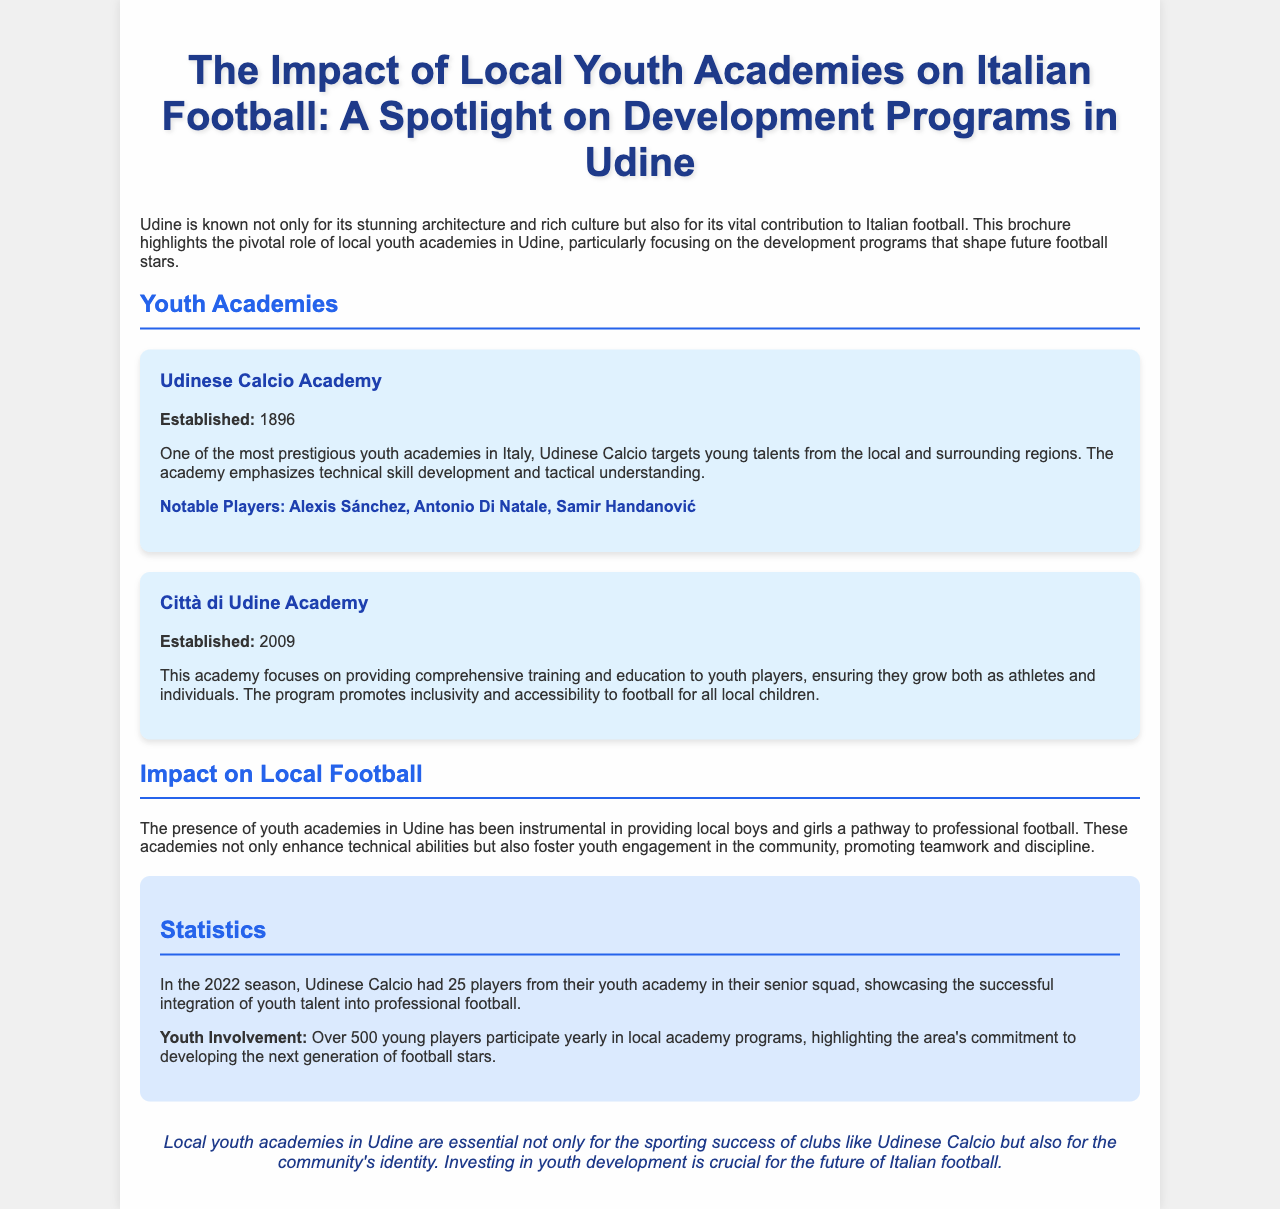What is the title of the brochure? The title provides the main focus of the document, emphasizing youth academies and their impact on local football in Udine.
Answer: The Impact of Local Youth Academies on Italian Football: A Spotlight on Development Programs in Udine When was the Udinese Calcio Academy established? The establishment date of the Udinese Calcio Academy is specifically mentioned in the document.
Answer: 1896 What notable player is associated with the Udinese Calcio Academy? The document lists notable players from this academy, highlighting its successful contributions to professional football.
Answer: Alexis Sánchez How many players from the Udinese Calcio Academy were in the senior squad during the 2022 season? This statistic indicates the integration of academy players into professional football.
Answer: 25 What is the primary focus of the Città di Udine Academy? The focus of this academy is described, showcasing its goals for youth development.
Answer: Comprehensive training and education How many young players participate yearly in local academy programs? This number reflects the scale of youth engagement in football within the community.
Answer: Over 500 What is a key benefit of local youth academies in Udine? The document states how these academies impact the youth and community positively.
Answer: Pathway to professional football What type of community values do youth academies promote? The document highlights important social values instilled by the academies.
Answer: Teamwork and discipline What essential role do local youth academies play according to the document? The conclusion indicates the academies' broader significance beyond just sporting success.
Answer: Community's identity 